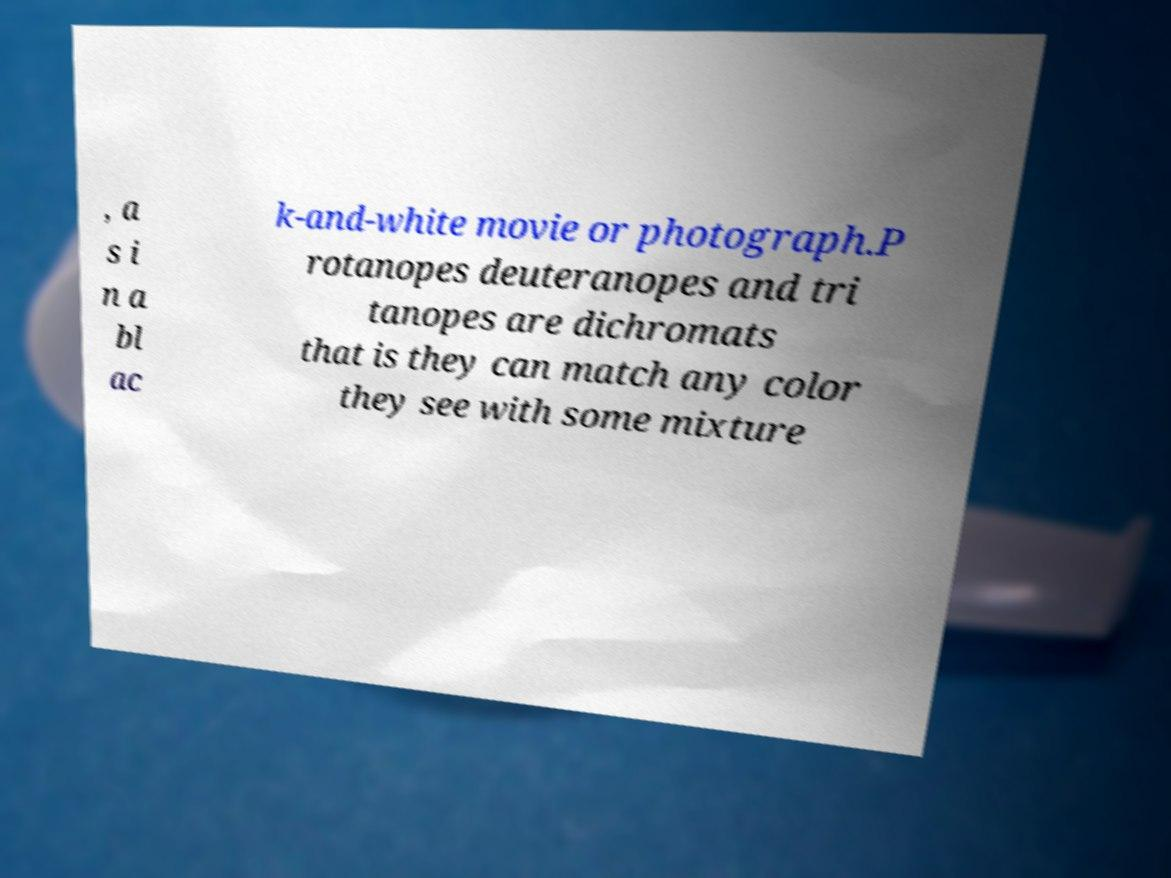For documentation purposes, I need the text within this image transcribed. Could you provide that? , a s i n a bl ac k-and-white movie or photograph.P rotanopes deuteranopes and tri tanopes are dichromats that is they can match any color they see with some mixture 